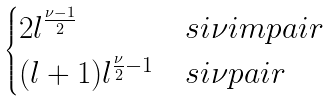Convert formula to latex. <formula><loc_0><loc_0><loc_500><loc_500>\begin{cases} 2 l ^ { \frac { \nu - 1 } { 2 } } & s i \nu i m p a i r \\ ( l + 1 ) l ^ { \frac { \nu } { 2 } - 1 } & s i \nu p a i r \end{cases}</formula> 